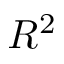Convert formula to latex. <formula><loc_0><loc_0><loc_500><loc_500>R ^ { 2 }</formula> 